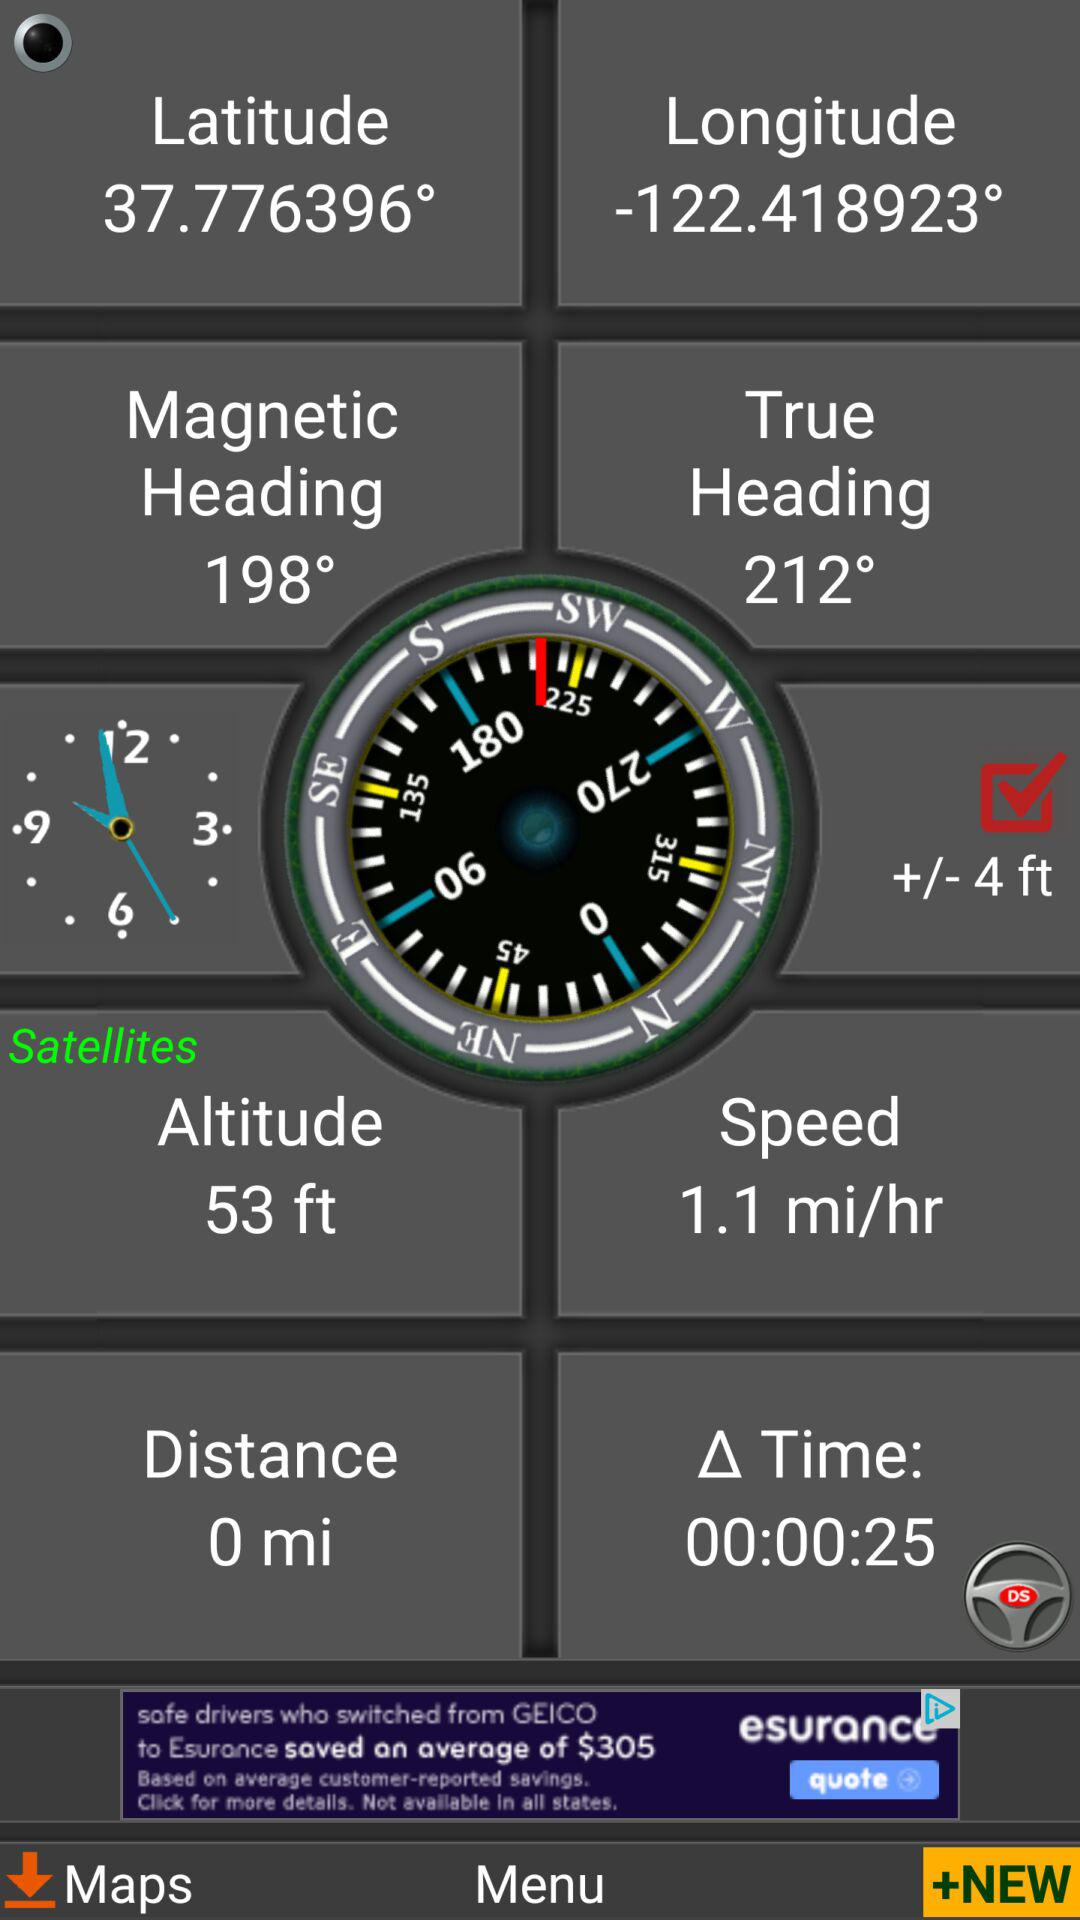How much time has passed since the last update?
Answer the question using a single word or phrase. 00:00:25 